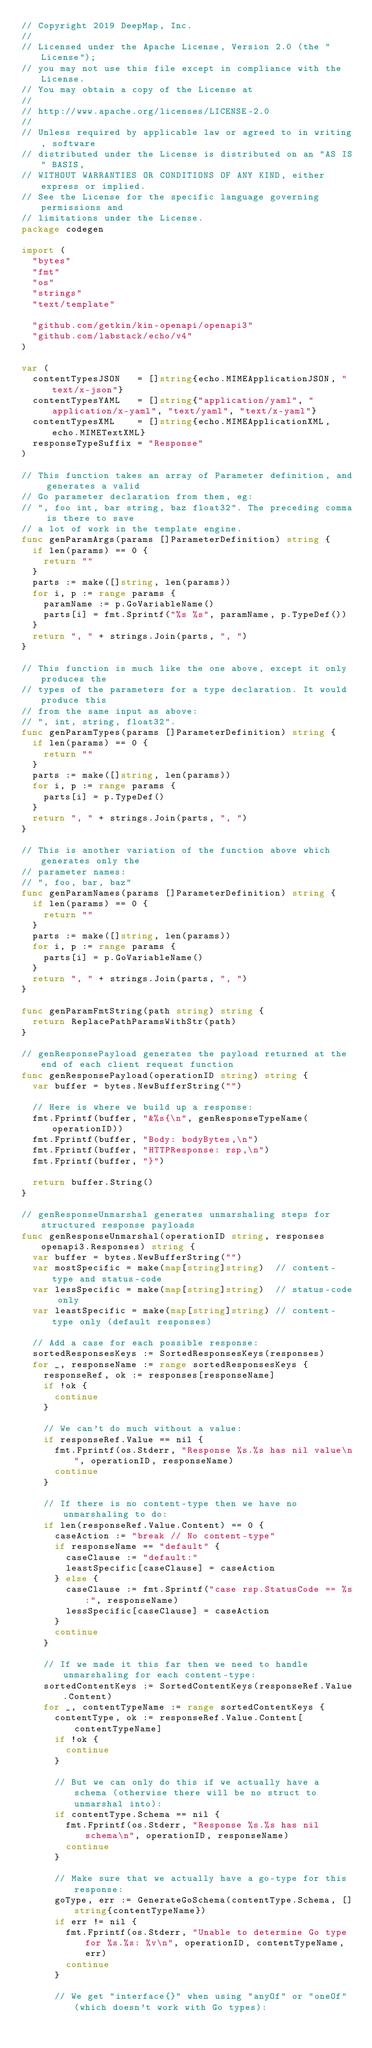Convert code to text. <code><loc_0><loc_0><loc_500><loc_500><_Go_>// Copyright 2019 DeepMap, Inc.
//
// Licensed under the Apache License, Version 2.0 (the "License");
// you may not use this file except in compliance with the License.
// You may obtain a copy of the License at
//
// http://www.apache.org/licenses/LICENSE-2.0
//
// Unless required by applicable law or agreed to in writing, software
// distributed under the License is distributed on an "AS IS" BASIS,
// WITHOUT WARRANTIES OR CONDITIONS OF ANY KIND, either express or implied.
// See the License for the specific language governing permissions and
// limitations under the License.
package codegen

import (
	"bytes"
	"fmt"
	"os"
	"strings"
	"text/template"

	"github.com/getkin/kin-openapi/openapi3"
	"github.com/labstack/echo/v4"
)

var (
	contentTypesJSON   = []string{echo.MIMEApplicationJSON, "text/x-json"}
	contentTypesYAML   = []string{"application/yaml", "application/x-yaml", "text/yaml", "text/x-yaml"}
	contentTypesXML    = []string{echo.MIMEApplicationXML, echo.MIMETextXML}
	responseTypeSuffix = "Response"
)

// This function takes an array of Parameter definition, and generates a valid
// Go parameter declaration from them, eg:
// ", foo int, bar string, baz float32". The preceding comma is there to save
// a lot of work in the template engine.
func genParamArgs(params []ParameterDefinition) string {
	if len(params) == 0 {
		return ""
	}
	parts := make([]string, len(params))
	for i, p := range params {
		paramName := p.GoVariableName()
		parts[i] = fmt.Sprintf("%s %s", paramName, p.TypeDef())
	}
	return ", " + strings.Join(parts, ", ")
}

// This function is much like the one above, except it only produces the
// types of the parameters for a type declaration. It would produce this
// from the same input as above:
// ", int, string, float32".
func genParamTypes(params []ParameterDefinition) string {
	if len(params) == 0 {
		return ""
	}
	parts := make([]string, len(params))
	for i, p := range params {
		parts[i] = p.TypeDef()
	}
	return ", " + strings.Join(parts, ", ")
}

// This is another variation of the function above which generates only the
// parameter names:
// ", foo, bar, baz"
func genParamNames(params []ParameterDefinition) string {
	if len(params) == 0 {
		return ""
	}
	parts := make([]string, len(params))
	for i, p := range params {
		parts[i] = p.GoVariableName()
	}
	return ", " + strings.Join(parts, ", ")
}

func genParamFmtString(path string) string {
	return ReplacePathParamsWithStr(path)
}

// genResponsePayload generates the payload returned at the end of each client request function
func genResponsePayload(operationID string) string {
	var buffer = bytes.NewBufferString("")

	// Here is where we build up a response:
	fmt.Fprintf(buffer, "&%s{\n", genResponseTypeName(operationID))
	fmt.Fprintf(buffer, "Body: bodyBytes,\n")
	fmt.Fprintf(buffer, "HTTPResponse: rsp,\n")
	fmt.Fprintf(buffer, "}")

	return buffer.String()
}

// genResponseUnmarshal generates unmarshaling steps for structured response payloads
func genResponseUnmarshal(operationID string, responses openapi3.Responses) string {
	var buffer = bytes.NewBufferString("")
	var mostSpecific = make(map[string]string)  // content-type and status-code
	var lessSpecific = make(map[string]string)  // status-code only
	var leastSpecific = make(map[string]string) // content-type only (default responses)

	// Add a case for each possible response:
	sortedResponsesKeys := SortedResponsesKeys(responses)
	for _, responseName := range sortedResponsesKeys {
		responseRef, ok := responses[responseName]
		if !ok {
			continue
		}

		// We can't do much without a value:
		if responseRef.Value == nil {
			fmt.Fprintf(os.Stderr, "Response %s.%s has nil value\n", operationID, responseName)
			continue
		}

		// If there is no content-type then we have no unmarshaling to do:
		if len(responseRef.Value.Content) == 0 {
			caseAction := "break // No content-type"
			if responseName == "default" {
				caseClause := "default:"
				leastSpecific[caseClause] = caseAction
			} else {
				caseClause := fmt.Sprintf("case rsp.StatusCode == %s:", responseName)
				lessSpecific[caseClause] = caseAction
			}
			continue
		}

		// If we made it this far then we need to handle unmarshaling for each content-type:
		sortedContentKeys := SortedContentKeys(responseRef.Value.Content)
		for _, contentTypeName := range sortedContentKeys {
			contentType, ok := responseRef.Value.Content[contentTypeName]
			if !ok {
				continue
			}

			// But we can only do this if we actually have a schema (otherwise there will be no struct to unmarshal into):
			if contentType.Schema == nil {
				fmt.Fprintf(os.Stderr, "Response %s.%s has nil schema\n", operationID, responseName)
				continue
			}

			// Make sure that we actually have a go-type for this response:
			goType, err := GenerateGoSchema(contentType.Schema, []string{contentTypeName})
			if err != nil {
				fmt.Fprintf(os.Stderr, "Unable to determine Go type for %s.%s: %v\n", operationID, contentTypeName, err)
				continue
			}

			// We get "interface{}" when using "anyOf" or "oneOf" (which doesn't work with Go types):</code> 